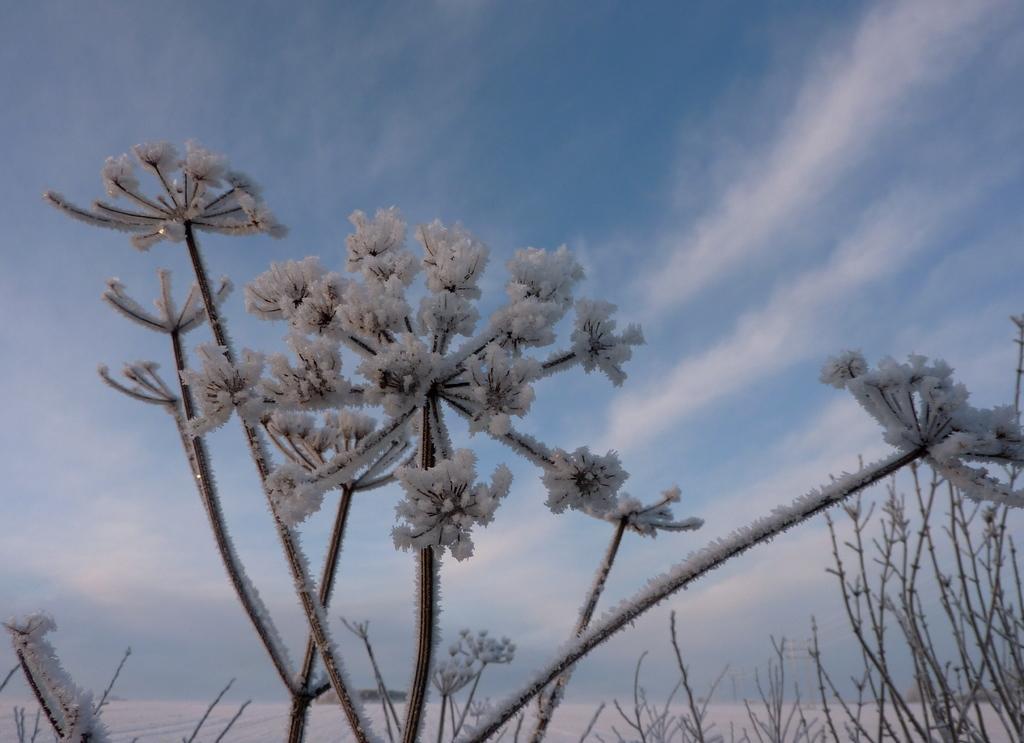Please provide a concise description of this image. In front of the picture, we see the plants and the flowers which are covered with the snow. At the bottom, we see the snow. In the background, we see the clouds and the sky, which is blue in color. 